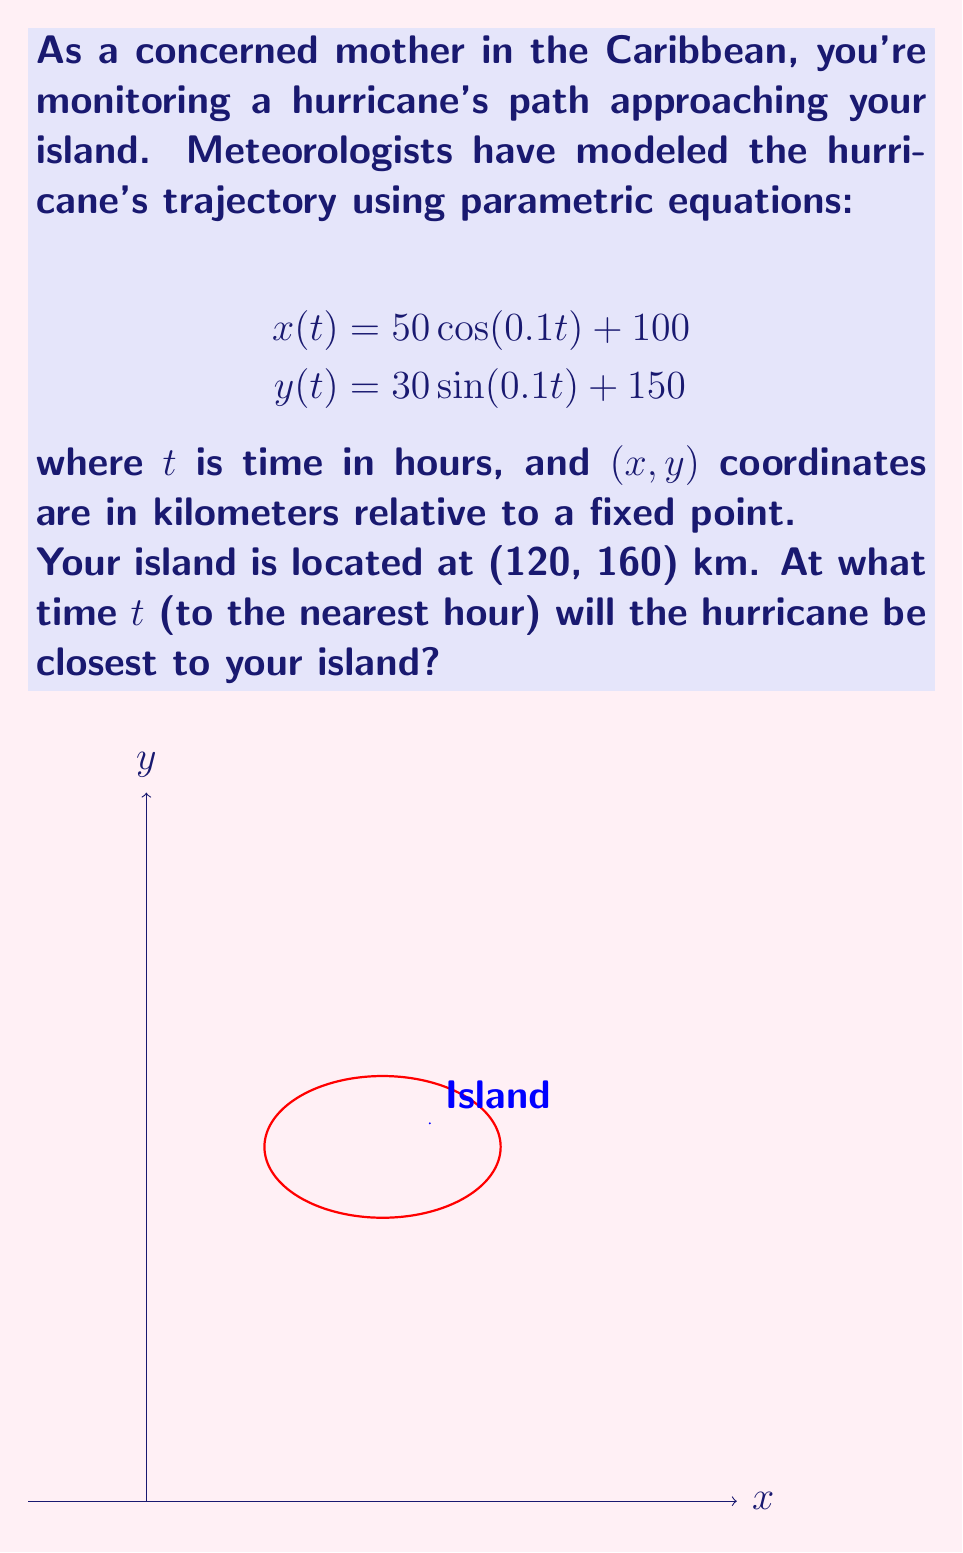Show me your answer to this math problem. Let's approach this step-by-step:

1) The distance $d$ between the hurricane and the island at any time $t$ is given by:

   $$d(t) = \sqrt{(x(t)-120)^2 + (y(t)-160)^2}$$

2) Substituting the parametric equations:

   $$d(t) = \sqrt{(50\cos(0.1t) + 100 - 120)^2 + (30\sin(0.1t) + 150 - 160)^2}$$
   $$d(t) = \sqrt{(50\cos(0.1t) - 20)^2 + (30\sin(0.1t) - 10)^2}$$

3) To find the minimum distance, we need to find where $\frac{d}{dt}[d(t)^2] = 0$. It's easier to work with $d(t)^2$:

   $$d(t)^2 = (50\cos(0.1t) - 20)^2 + (30\sin(0.1t) - 10)^2$$

4) Differentiating with respect to $t$:

   $$\frac{d}{dt}[d(t)^2] = 2(50\cos(0.1t) - 20)(-5\sin(0.1t)) + 2(30\sin(0.1t) - 10)(3\cos(0.1t))$$

5) Setting this equal to zero:

   $$-500\cos(0.1t)\sin(0.1t) + 100\sin(0.1t) + 180\sin(0.1t)\cos(0.1t) - 60\cos(0.1t) = 0$$

6) Simplifying:

   $$-320\cos(0.1t)\sin(0.1t) + 100\sin(0.1t) - 60\cos(0.1t) = 0$$

7) This equation can be solved numerically. Using a calculator or computer, we find that the solution is approximately:

   $$t \approx 15.7$$

8) Rounding to the nearest hour:

   $$t \approx 16$$

We can verify this by calculating the distance at $t=15, 16,$ and $17$ hours to confirm that 16 hours gives the minimum distance.
Answer: 16 hours 